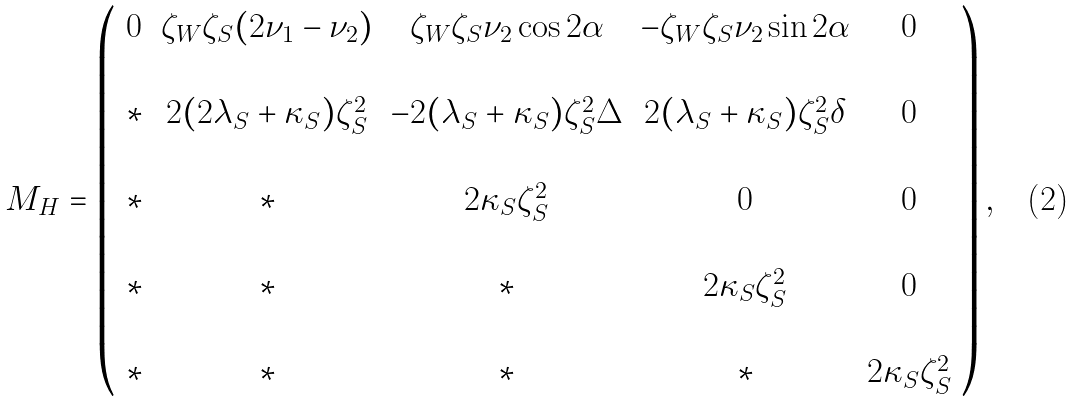Convert formula to latex. <formula><loc_0><loc_0><loc_500><loc_500>M _ { H } = \left ( \begin{array} { c c c c c } 0 & \zeta _ { W } \zeta _ { S } ( 2 \nu _ { 1 } - \nu _ { 2 } ) & \zeta _ { W } \zeta _ { S } \nu _ { 2 } \cos 2 \alpha & - \zeta _ { W } \zeta _ { S } \nu _ { 2 } \sin 2 \alpha & 0 \\ \ \\ { * } & 2 ( 2 \lambda _ { S } + \kappa _ { S } ) \zeta _ { S } ^ { 2 } & - 2 ( \lambda _ { S } + \kappa _ { S } ) \zeta _ { S } ^ { 2 } \Delta & 2 ( \lambda _ { S } + \kappa _ { S } ) \zeta _ { S } ^ { 2 } \delta & 0 \\ \ \\ { * } & * & 2 \kappa _ { S } \zeta _ { S } ^ { 2 } & 0 & 0 \\ \ \\ { * } & * & * & 2 \kappa _ { S } \zeta _ { S } ^ { 2 } & 0 \\ \ \\ { * } & * & * & * & 2 \kappa _ { S } \zeta _ { S } ^ { 2 } \end{array} \right ) ,</formula> 